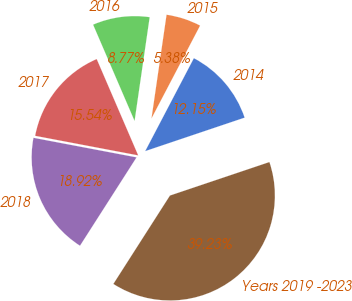<chart> <loc_0><loc_0><loc_500><loc_500><pie_chart><fcel>2014<fcel>2015<fcel>2016<fcel>2017<fcel>2018<fcel>Years 2019 -2023<nl><fcel>12.15%<fcel>5.38%<fcel>8.77%<fcel>15.54%<fcel>18.92%<fcel>39.23%<nl></chart> 